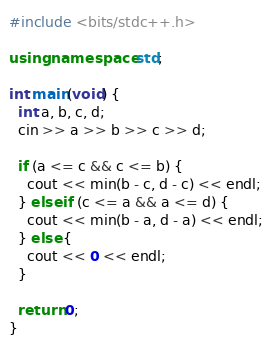<code> <loc_0><loc_0><loc_500><loc_500><_C++_>#include <bits/stdc++.h>

using namespace std;

int main(void) {
  int a, b, c, d;
  cin >> a >> b >> c >> d;

  if (a <= c && c <= b) {
    cout << min(b - c, d - c) << endl;
  } else if (c <= a && a <= d) {
    cout << min(b - a, d - a) << endl;
  } else {
    cout << 0 << endl;
  }
  
  return 0;
}</code> 